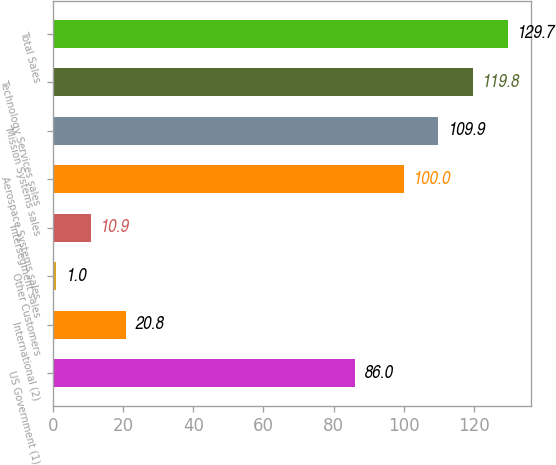Convert chart. <chart><loc_0><loc_0><loc_500><loc_500><bar_chart><fcel>US Government (1)<fcel>International (2)<fcel>Other Customers<fcel>Intersegment sales<fcel>Aerospace Systems sales<fcel>Mission Systems sales<fcel>Technology Services sales<fcel>Total Sales<nl><fcel>86<fcel>20.8<fcel>1<fcel>10.9<fcel>100<fcel>109.9<fcel>119.8<fcel>129.7<nl></chart> 